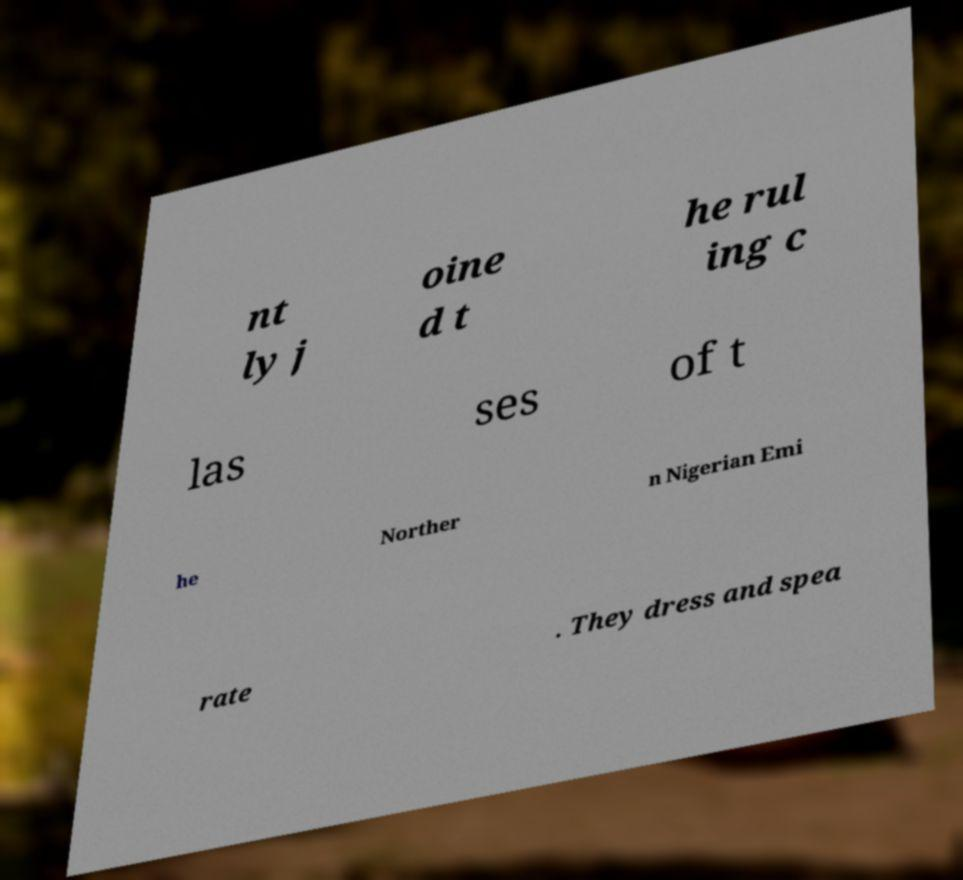Could you assist in decoding the text presented in this image and type it out clearly? nt ly j oine d t he rul ing c las ses of t he Norther n Nigerian Emi rate . They dress and spea 